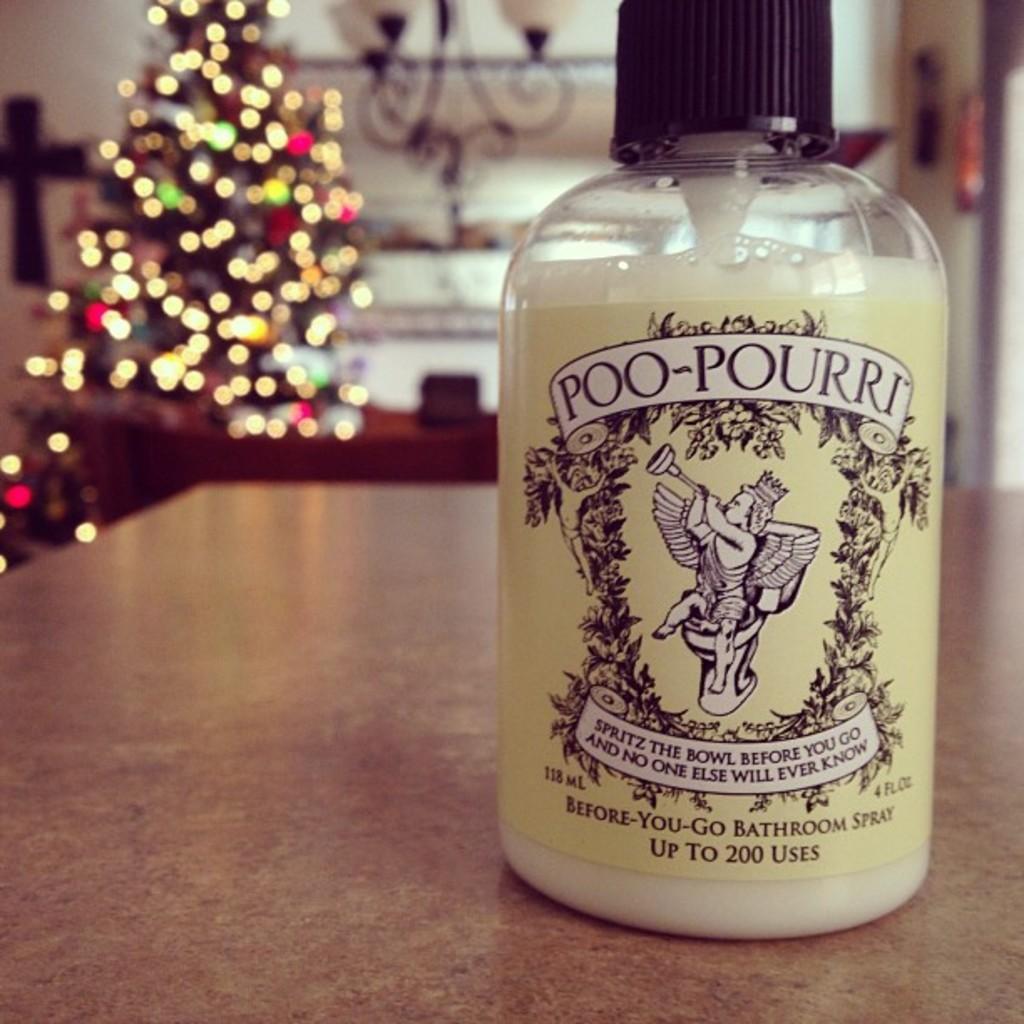In one or two sentences, can you explain what this image depicts? Here we can see a bottle with a label on it, and some liquid in it, and at back here is the x-mass tree. 